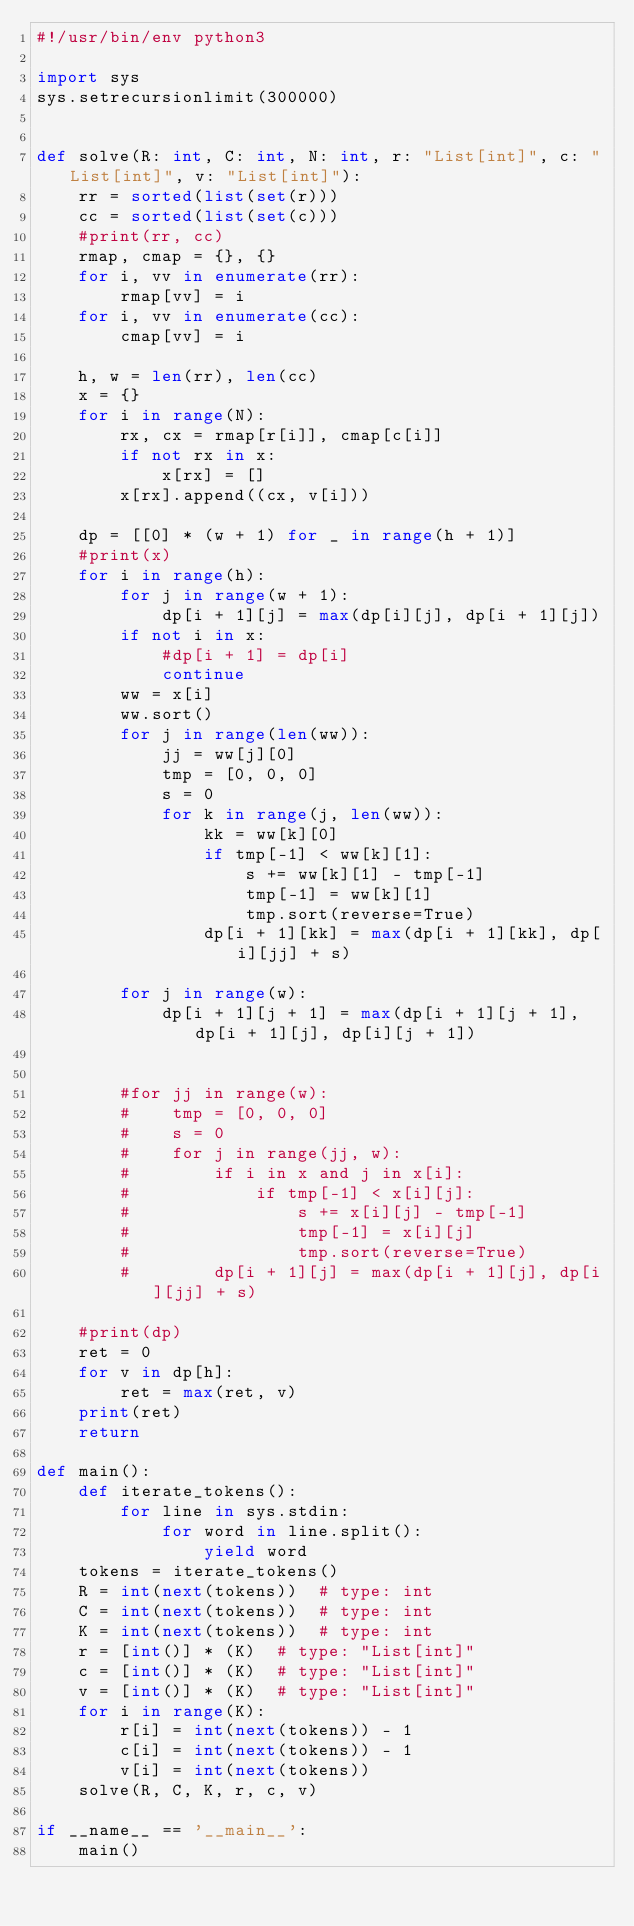<code> <loc_0><loc_0><loc_500><loc_500><_Python_>#!/usr/bin/env python3

import sys
sys.setrecursionlimit(300000)


def solve(R: int, C: int, N: int, r: "List[int]", c: "List[int]", v: "List[int]"):
    rr = sorted(list(set(r)))
    cc = sorted(list(set(c)))
    #print(rr, cc)
    rmap, cmap = {}, {}
    for i, vv in enumerate(rr):
        rmap[vv] = i
    for i, vv in enumerate(cc):
        cmap[vv] = i

    h, w = len(rr), len(cc)
    x = {}
    for i in range(N):
        rx, cx = rmap[r[i]], cmap[c[i]]
        if not rx in x:
            x[rx] = []
        x[rx].append((cx, v[i]))

    dp = [[0] * (w + 1) for _ in range(h + 1)]
    #print(x)
    for i in range(h):
        for j in range(w + 1):
            dp[i + 1][j] = max(dp[i][j], dp[i + 1][j])
        if not i in x:
            #dp[i + 1] = dp[i]
            continue
        ww = x[i]
        ww.sort()
        for j in range(len(ww)):
            jj = ww[j][0]
            tmp = [0, 0, 0]
            s = 0
            for k in range(j, len(ww)):
                kk = ww[k][0]
                if tmp[-1] < ww[k][1]:
                    s += ww[k][1] - tmp[-1] 
                    tmp[-1] = ww[k][1]
                    tmp.sort(reverse=True)
                dp[i + 1][kk] = max(dp[i + 1][kk], dp[i][jj] + s)

        for j in range(w):
            dp[i + 1][j + 1] = max(dp[i + 1][j + 1], dp[i + 1][j], dp[i][j + 1])


        #for jj in range(w):
        #    tmp = [0, 0, 0]
        #    s = 0
        #    for j in range(jj, w):
        #        if i in x and j in x[i]:
        #            if tmp[-1] < x[i][j]:
        #                s += x[i][j] - tmp[-1] 
        #                tmp[-1] = x[i][j]
        #                tmp.sort(reverse=True)
        #        dp[i + 1][j] = max(dp[i + 1][j], dp[i][jj] + s)

    #print(dp)
    ret = 0
    for v in dp[h]:
        ret = max(ret, v)
    print(ret)
    return

def main():
    def iterate_tokens():
        for line in sys.stdin:
            for word in line.split():
                yield word
    tokens = iterate_tokens()
    R = int(next(tokens))  # type: int
    C = int(next(tokens))  # type: int
    K = int(next(tokens))  # type: int
    r = [int()] * (K)  # type: "List[int]"
    c = [int()] * (K)  # type: "List[int]"
    v = [int()] * (K)  # type: "List[int]"
    for i in range(K):
        r[i] = int(next(tokens)) - 1
        c[i] = int(next(tokens)) - 1
        v[i] = int(next(tokens))
    solve(R, C, K, r, c, v)

if __name__ == '__main__':
    main()
</code> 